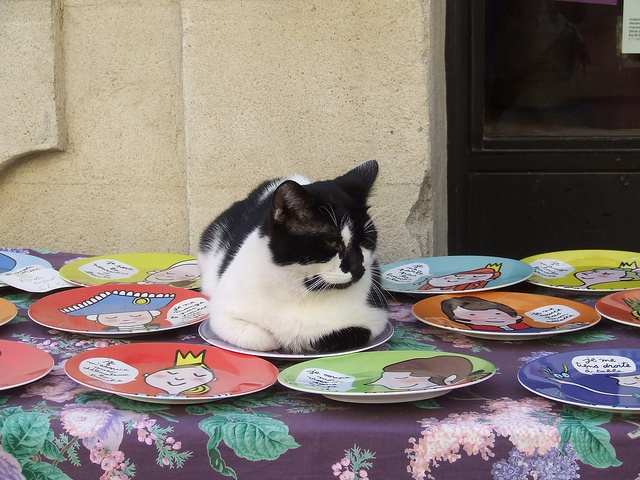Describe the objects in this image and their specific colors. I can see dining table in tan, gray, lightgray, black, and darkgray tones and cat in tan, black, lightgray, darkgray, and gray tones in this image. 